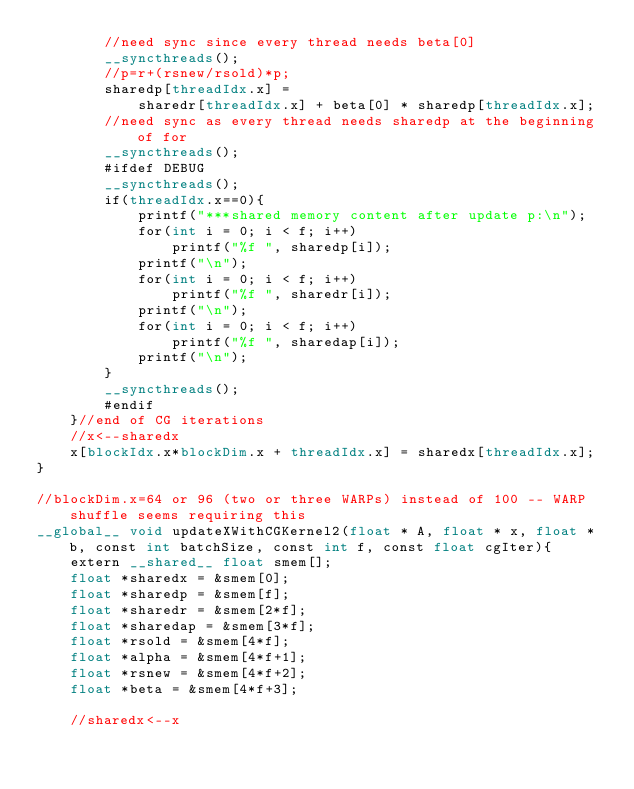<code> <loc_0><loc_0><loc_500><loc_500><_Cuda_>		//need sync since every thread needs beta[0]
		__syncthreads();
		//p=r+(rsnew/rsold)*p;
		sharedp[threadIdx.x] = 
			sharedr[threadIdx.x] + beta[0] * sharedp[threadIdx.x];
		//need sync as every thread needs sharedp at the beginning of for
		__syncthreads();
		#ifdef DEBUG
		__syncthreads();
		if(threadIdx.x==0){
			printf("***shared memory content after update p:\n");
			for(int i = 0; i < f; i++)
				printf("%f ", sharedp[i]);
			printf("\n");
			for(int i = 0; i < f; i++)
				printf("%f ", sharedr[i]);
			printf("\n");
			for(int i = 0; i < f; i++)
				printf("%f ", sharedap[i]);
			printf("\n");
		}
		__syncthreads();
		#endif
	}//end of CG iterations
	//x<--sharedx
	x[blockIdx.x*blockDim.x + threadIdx.x] = sharedx[threadIdx.x];
}

//blockDim.x=64 or 96 (two or three WARPs) instead of 100 -- WARP shuffle seems requiring this
__global__ void updateXWithCGKernel2(float * A, float * x, float * b, const int batchSize, const int f, const float cgIter){
	extern __shared__ float smem[];
	float *sharedx = &smem[0];
	float *sharedp = &smem[f];
	float *sharedr = &smem[2*f];
	float *sharedap = &smem[3*f];
	float *rsold = &smem[4*f]; 
	float *alpha = &smem[4*f+1];
	float *rsnew = &smem[4*f+2];
	float *beta = &smem[4*f+3];

	//sharedx<--x</code> 